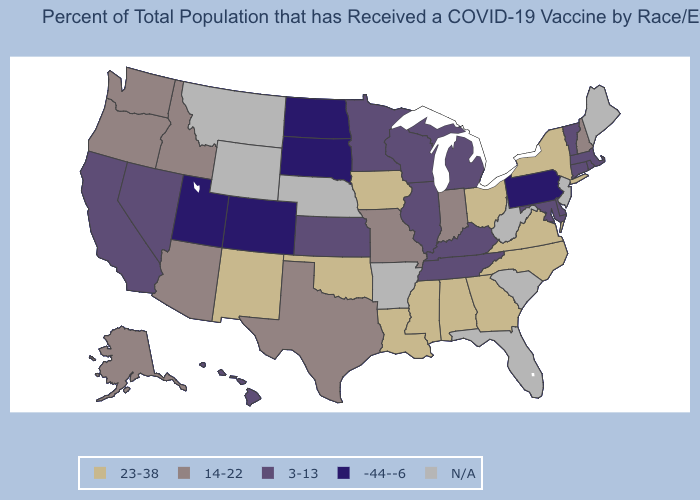Name the states that have a value in the range N/A?
Answer briefly. Arkansas, Florida, Maine, Montana, Nebraska, New Jersey, South Carolina, West Virginia, Wyoming. What is the value of Missouri?
Answer briefly. 14-22. Which states have the lowest value in the West?
Concise answer only. Colorado, Utah. Which states hav the highest value in the West?
Concise answer only. New Mexico. Does Massachusetts have the highest value in the USA?
Concise answer only. No. Name the states that have a value in the range N/A?
Be succinct. Arkansas, Florida, Maine, Montana, Nebraska, New Jersey, South Carolina, West Virginia, Wyoming. Name the states that have a value in the range 14-22?
Quick response, please. Alaska, Arizona, Idaho, Indiana, Missouri, New Hampshire, Oregon, Texas, Washington. What is the value of North Carolina?
Be succinct. 23-38. Is the legend a continuous bar?
Concise answer only. No. What is the highest value in the Northeast ?
Short answer required. 23-38. What is the lowest value in states that border New Hampshire?
Give a very brief answer. 3-13. Which states have the lowest value in the USA?
Concise answer only. Colorado, North Dakota, Pennsylvania, South Dakota, Utah. Name the states that have a value in the range N/A?
Answer briefly. Arkansas, Florida, Maine, Montana, Nebraska, New Jersey, South Carolina, West Virginia, Wyoming. 